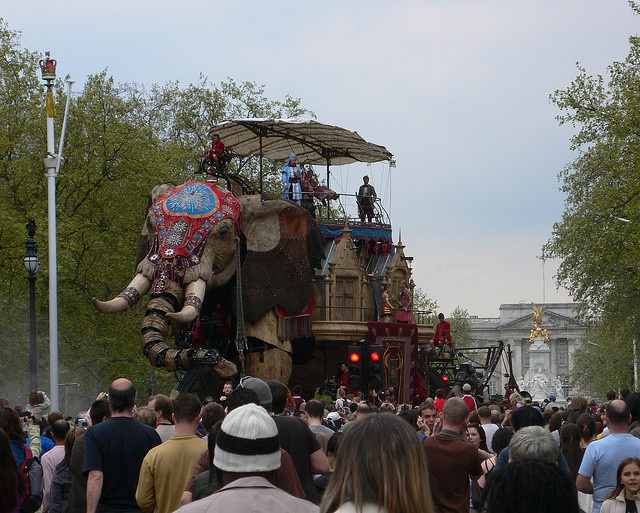Describe the objects in this image and their specific colors. I can see elephant in lightgray, black, gray, and maroon tones, people in lightgray, black, and gray tones, people in lightgray, darkgray, black, and gray tones, people in lightgray, black, gray, and maroon tones, and umbrella in lightgray, gray, and black tones in this image. 